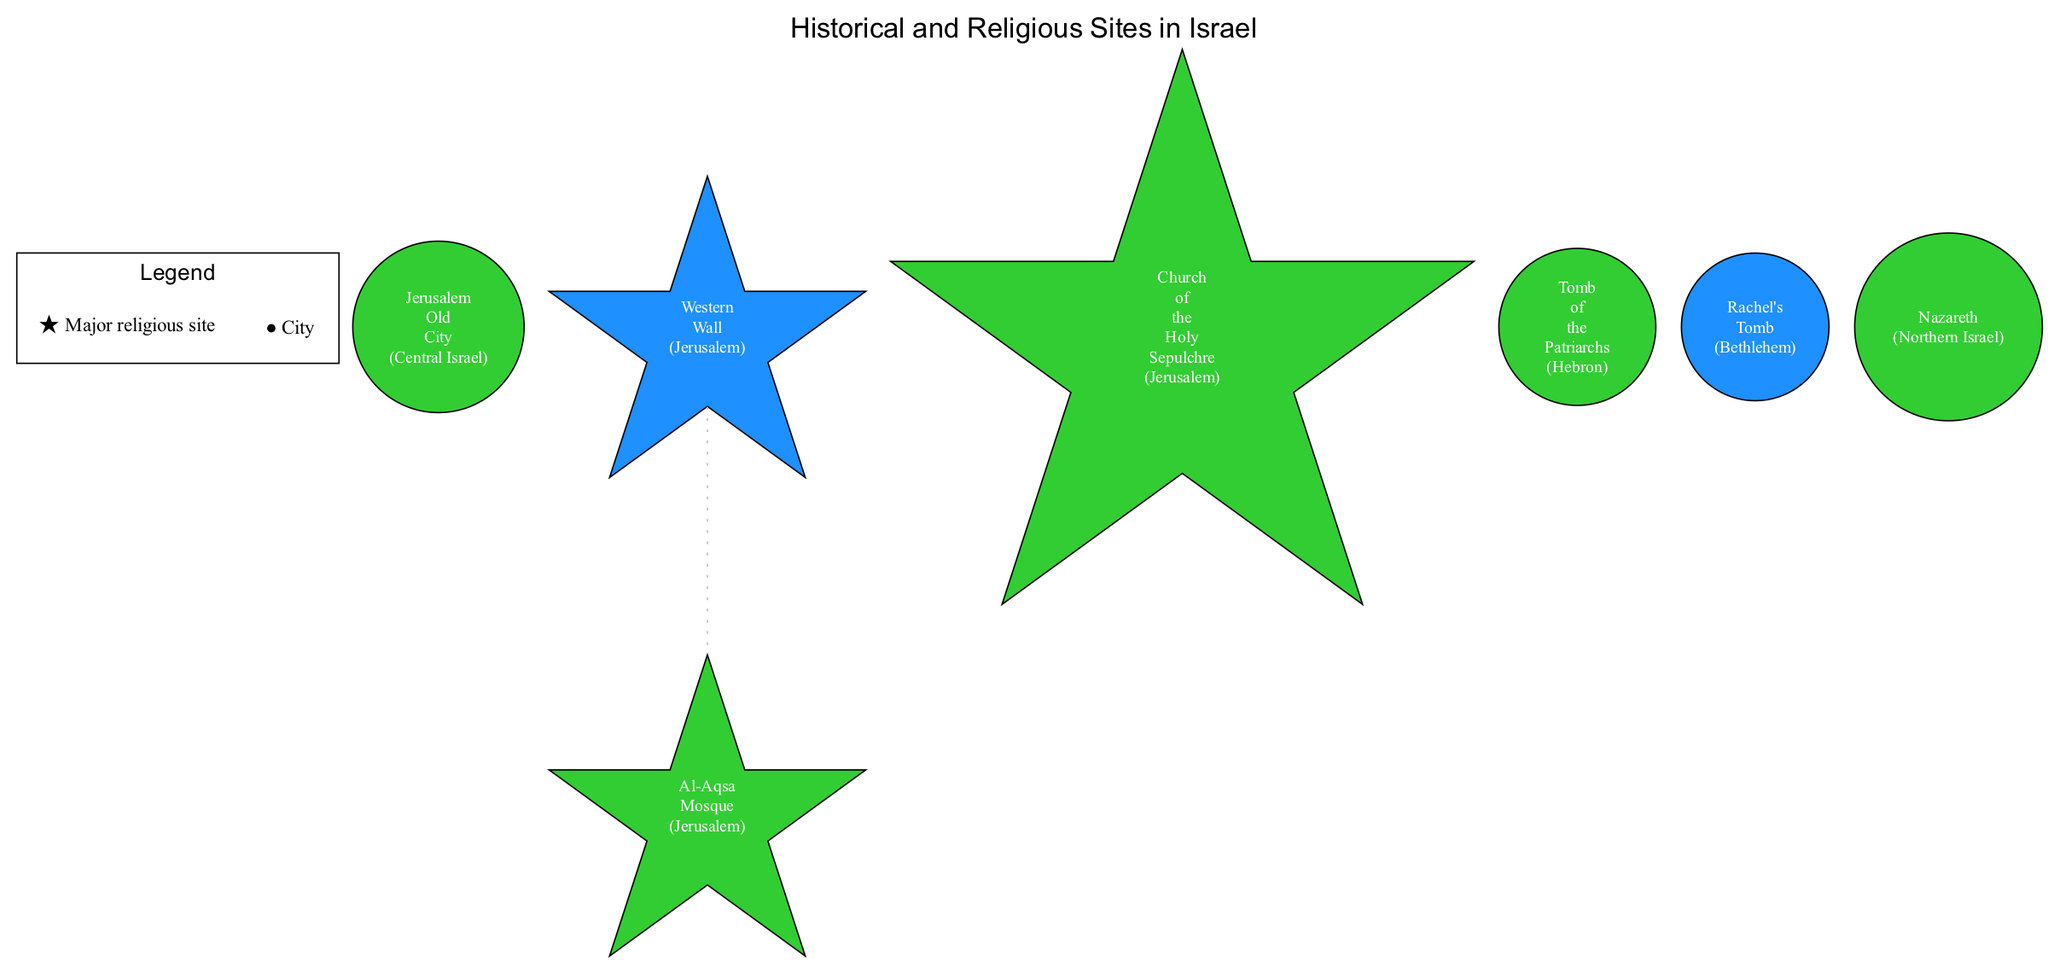What is the significance of the Western Wall? The Western Wall is labeled as a Jewish holy site in the diagram and is located in Jerusalem.
Answer: Jewish holy site How many major religious sites are marked in the diagram? The diagram includes multiple sites marked as major religious sites, specifically referring to those that have the star symbol. In reviewing the sites listed, the Western Wall, Al-Aqsa Mosque, Church of the Holy Sepulchre, and the Tomb of the Patriarchs qualify. Counting these gives a total of 4 major religious sites.
Answer: 4 Which site is significant for both Jews and Muslims? The Tomb of the Patriarchs is indicated to be sacred to both Jews and Muslims in the description provided for that site.
Answer: Tomb of the Patriarchs Where is the Church of the Holy Sepulchre located? The Church of the Holy Sepulchre is located in Jerusalem, as specified in the diagram.
Answer: Jerusalem What color represents Jewish holy sites on the map? Holy sites for Jews are depicted in a color consistent with the representations specified; in this case, it is blue.
Answer: Blue How are the sites in the same location connected? The diagram uses dotted gray lines to connect sites that are located in the same city, highlighting their geographical and relational closeness.
Answer: Dotted gray lines Which city is associated with both a Jewish tomb and a Muslim pilgrimage site? Bethlehem features both Rachel's Tomb, which is a pilgrimage site for Jews, and is significant for Muslims, indicating its importance for both communities.
Answer: Bethlehem How many sites are located in Jerusalem? By reviewing the diagram, we find that there are four sites listed as being in Jerusalem: the Western Wall, Al-Aqsa Mosque, Church of the Holy Sepulchre, and Jerusalem Old City, making a total of 4 sites.
Answer: 4 